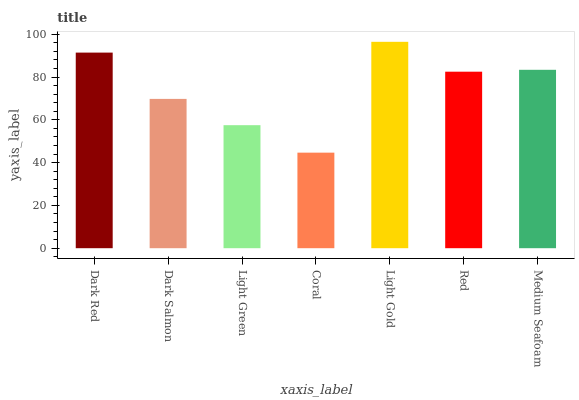Is Dark Salmon the minimum?
Answer yes or no. No. Is Dark Salmon the maximum?
Answer yes or no. No. Is Dark Red greater than Dark Salmon?
Answer yes or no. Yes. Is Dark Salmon less than Dark Red?
Answer yes or no. Yes. Is Dark Salmon greater than Dark Red?
Answer yes or no. No. Is Dark Red less than Dark Salmon?
Answer yes or no. No. Is Red the high median?
Answer yes or no. Yes. Is Red the low median?
Answer yes or no. Yes. Is Dark Red the high median?
Answer yes or no. No. Is Light Gold the low median?
Answer yes or no. No. 